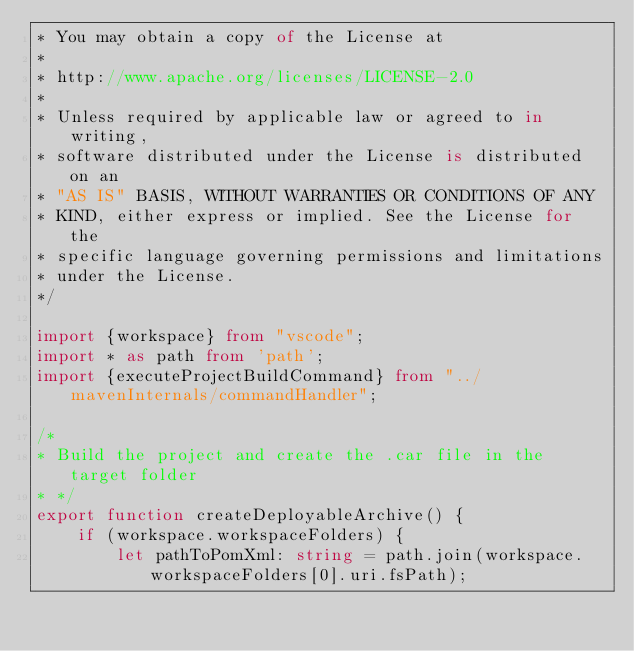Convert code to text. <code><loc_0><loc_0><loc_500><loc_500><_TypeScript_>* You may obtain a copy of the License at
*
* http://www.apache.org/licenses/LICENSE-2.0
*
* Unless required by applicable law or agreed to in writing,
* software distributed under the License is distributed on an
* "AS IS" BASIS, WITHOUT WARRANTIES OR CONDITIONS OF ANY
* KIND, either express or implied. See the License for the
* specific language governing permissions and limitations
* under the License.
*/

import {workspace} from "vscode";
import * as path from 'path';
import {executeProjectBuildCommand} from "../mavenInternals/commandHandler";

/*
* Build the project and create the .car file in the target folder
* */
export function createDeployableArchive() {
    if (workspace.workspaceFolders) {
        let pathToPomXml: string = path.join(workspace.workspaceFolders[0].uri.fsPath);
</code> 